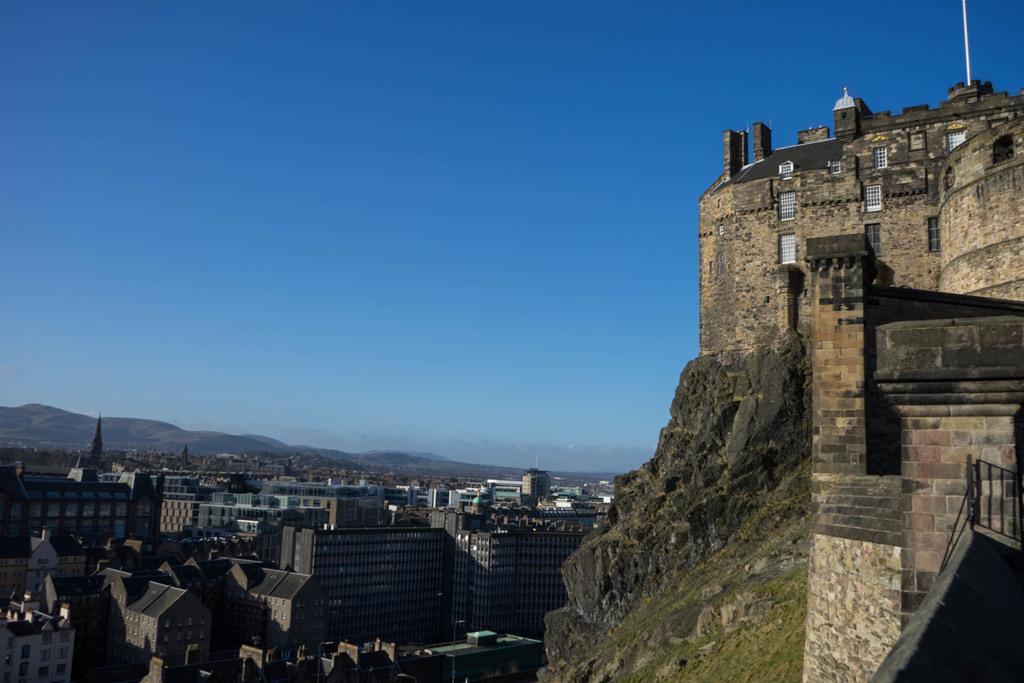Could you give a brief overview of what you see in this image? In the right of the image there is a monument on the hill. In the left there are many buildings and some towers and also hills. Sky is visible at the top. 